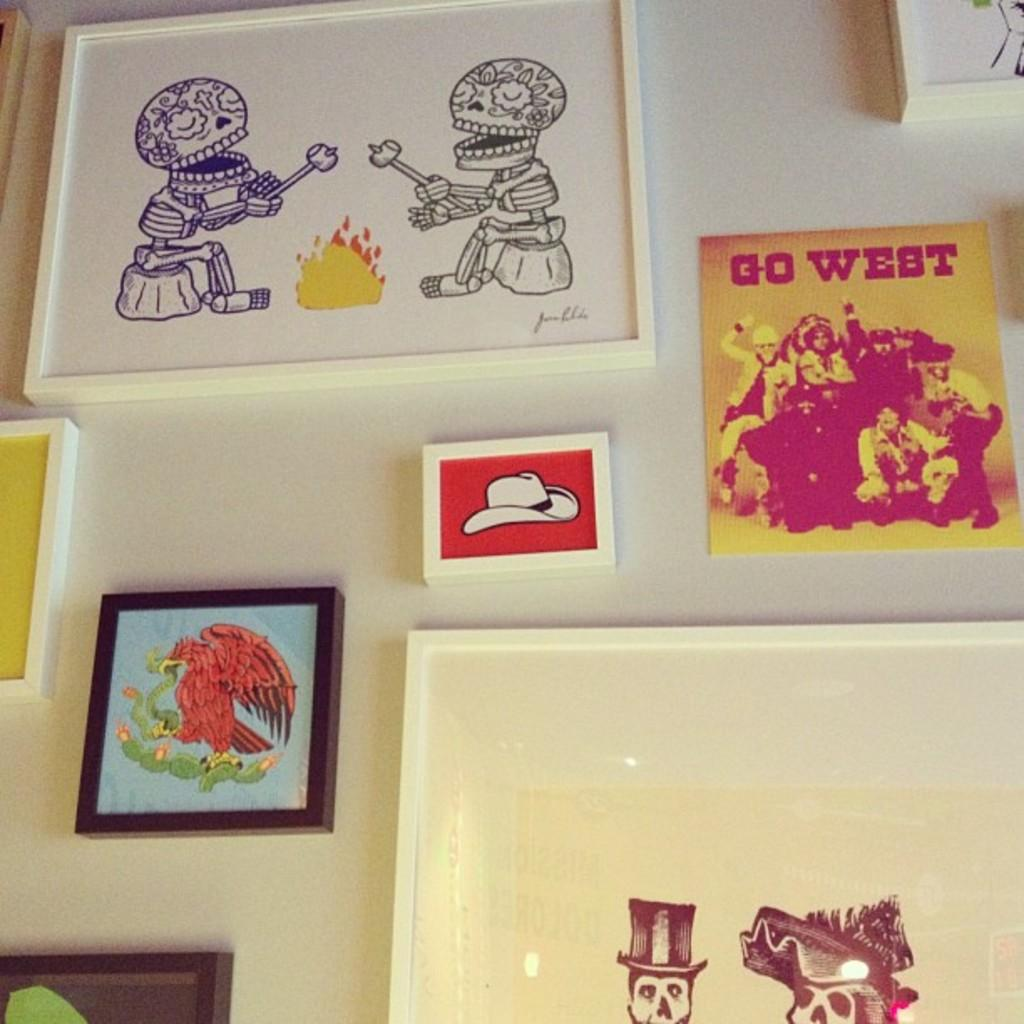Provide a one-sentence caption for the provided image. A number of works art are displayed including one titled GO WEST. 